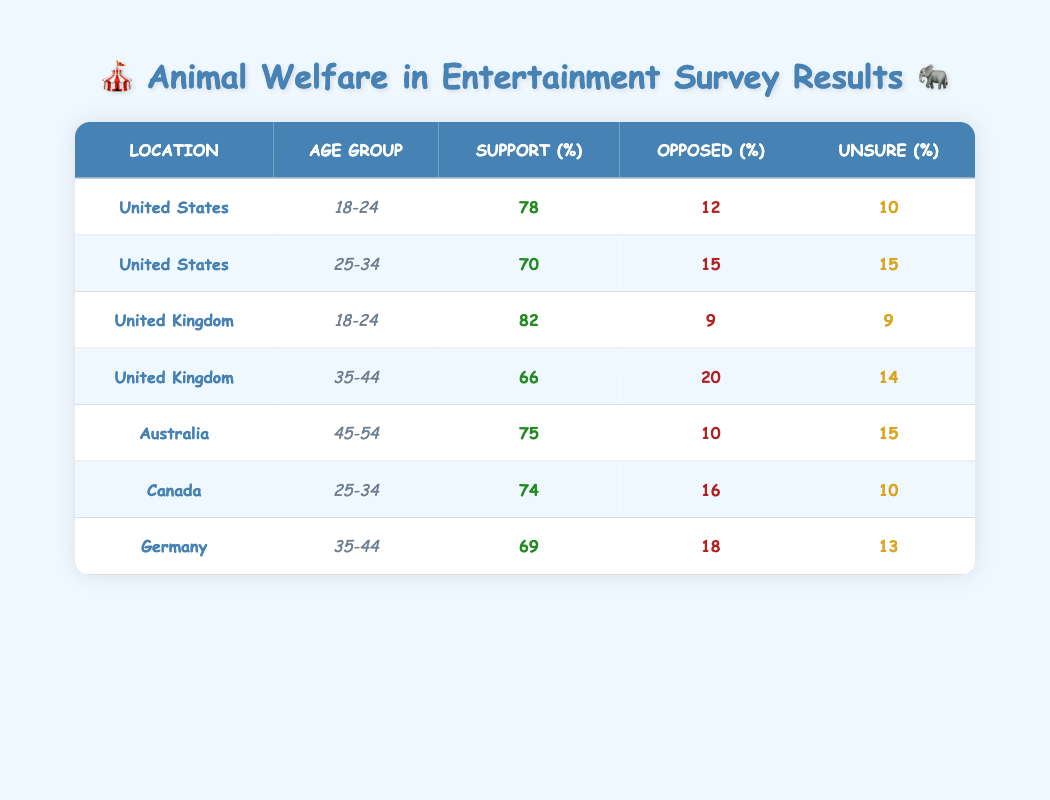What is the percentage of support for animal welfare entertainment among 18-24 year-olds in the United States? The table shows that the percentage of support for animal welfare entertainment among 18-24 year-olds in the United States is 78%.
Answer: 78% Which location has the highest percentage of individuals opposing animal entertainment? By examining the table, we see that the United Kingdom's age group 35-44 has 20% opposed to animal entertainment, which is the highest percentage compared to all other locations.
Answer: United Kingdom (35-44) What is the average support percentage for animal welfare entertainment across all age groups in Canada? In Canada, there's only one row which shows 74% support for the 25-34 age group. Thus, the average support percentage for Canada is simply this value: 74%.
Answer: 74% True or False: In Germany, the majority of respondents (more than 50%) support animal welfare in entertainment. Looking at the table, the percentage of support for animal welfare entertainment in Germany (35-44 age group) is 69%, which is greater than 50%. Therefore, this statement is true.
Answer: True What is the difference in the percentage of support for animal welfare entertainment between the United Kingdom (18-24 age group) and the United States (25-34 age group)? The United Kingdom (18-24 age group) shows 82% support, while the United States (25-34 age group) shows 70% support. The difference is calculated as 82% - 70% = 12%.
Answer: 12% What percentage of respondents in Australia were unsure about animal entertainment? From the table, in Australia (age group 45-54), the percentage of respondents who were unsure about animal entertainment is 15%.
Answer: 15% What is the median percentage of opposition to animal entertainment across all locations? To find the median percentage of opposition, list the opposition percentages: 12%, 15%, 9%, 20%, 10%, 16%, 18% and order them: 9%, 10%, 12%, 15%, 16%, 18%, 20%. The median (middle value) for this 7 value list is the 4th value, which is 15%.
Answer: 15% Which age group in the United States shows the least support for animal welfare in entertainment? Based on the table, the least support for animal welfare in entertainment in the United States is found in the 25-34 age group, with a support percentage of 70%.
Answer: 25-34 age group How does the percentage of respondents opposing animal entertainment in Canada compare to that in the United Kingdom (35-44 age group)? Canada (25-34 age group) has an opposition percentage of 16%, while the United Kingdom (35-44 age group) has an opposition percentage of 20%. Comparatively, the opposition in Canada is lower than in the United Kingdom, by a difference of 4%.
Answer: Canada has lower opposition by 4% 